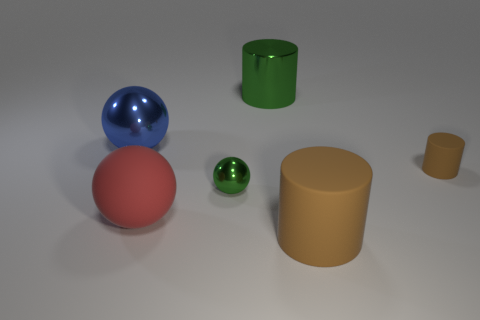Subtract all brown cylinders. How many cylinders are left? 1 Subtract all blue balls. How many balls are left? 2 Add 3 purple matte objects. How many objects exist? 9 Subtract 0 gray cylinders. How many objects are left? 6 Subtract 1 balls. How many balls are left? 2 Subtract all purple spheres. Subtract all gray blocks. How many spheres are left? 3 Subtract all green balls. How many red cylinders are left? 0 Subtract all rubber cylinders. Subtract all red balls. How many objects are left? 3 Add 6 rubber things. How many rubber things are left? 9 Add 1 large blue objects. How many large blue objects exist? 2 